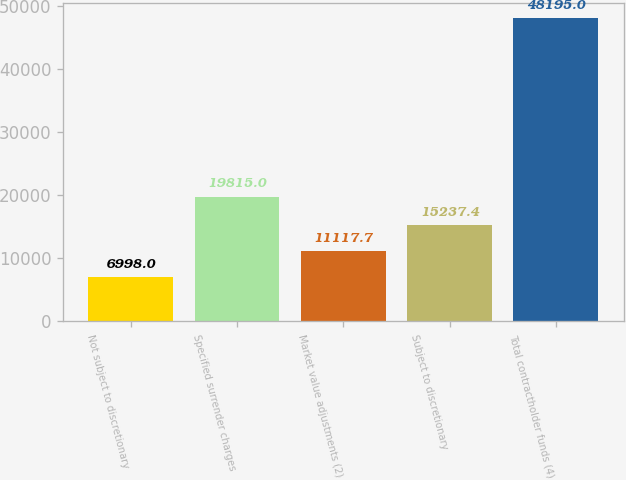<chart> <loc_0><loc_0><loc_500><loc_500><bar_chart><fcel>Not subject to discretionary<fcel>Specified surrender charges<fcel>Market value adjustments (2)<fcel>Subject to discretionary<fcel>Total contractholder funds (4)<nl><fcel>6998<fcel>19815<fcel>11117.7<fcel>15237.4<fcel>48195<nl></chart> 